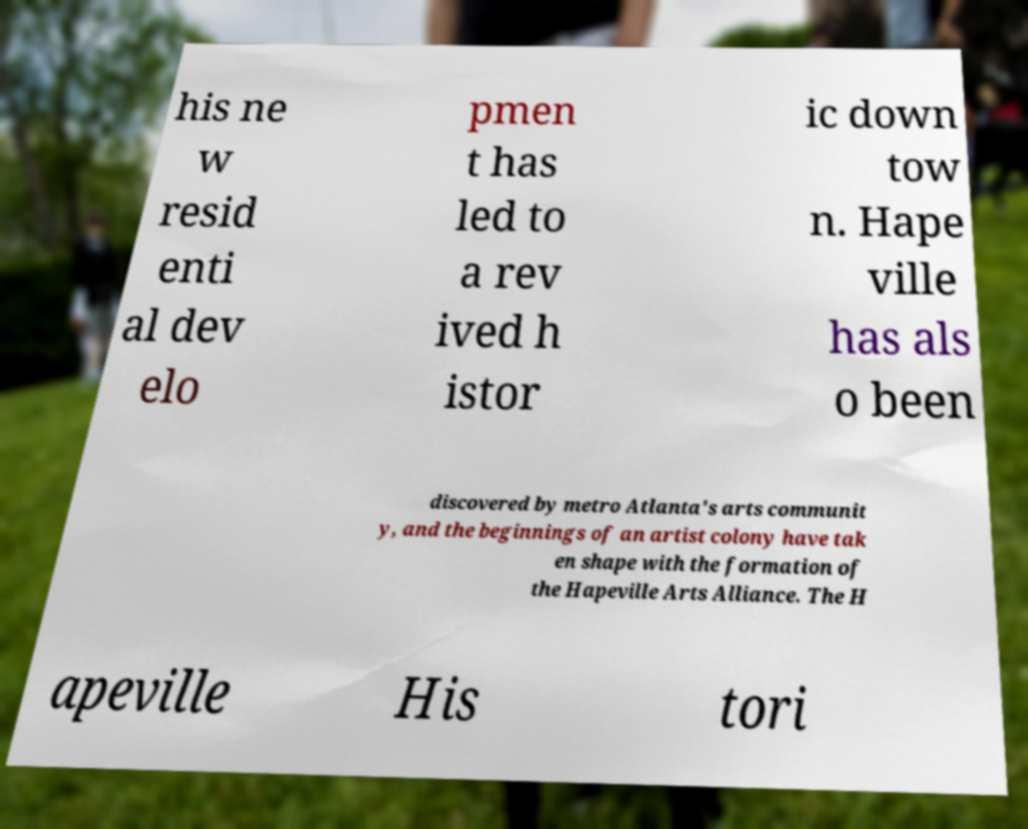There's text embedded in this image that I need extracted. Can you transcribe it verbatim? his ne w resid enti al dev elo pmen t has led to a rev ived h istor ic down tow n. Hape ville has als o been discovered by metro Atlanta's arts communit y, and the beginnings of an artist colony have tak en shape with the formation of the Hapeville Arts Alliance. The H apeville His tori 